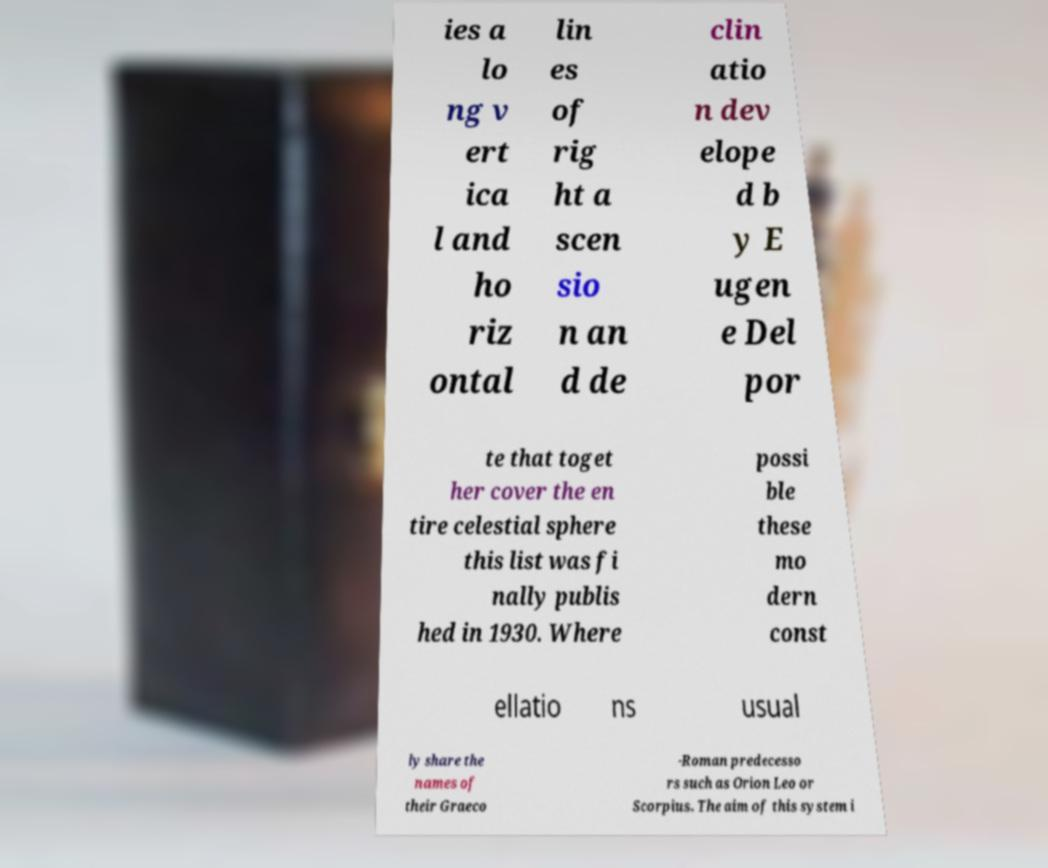Please identify and transcribe the text found in this image. ies a lo ng v ert ica l and ho riz ontal lin es of rig ht a scen sio n an d de clin atio n dev elope d b y E ugen e Del por te that toget her cover the en tire celestial sphere this list was fi nally publis hed in 1930. Where possi ble these mo dern const ellatio ns usual ly share the names of their Graeco -Roman predecesso rs such as Orion Leo or Scorpius. The aim of this system i 